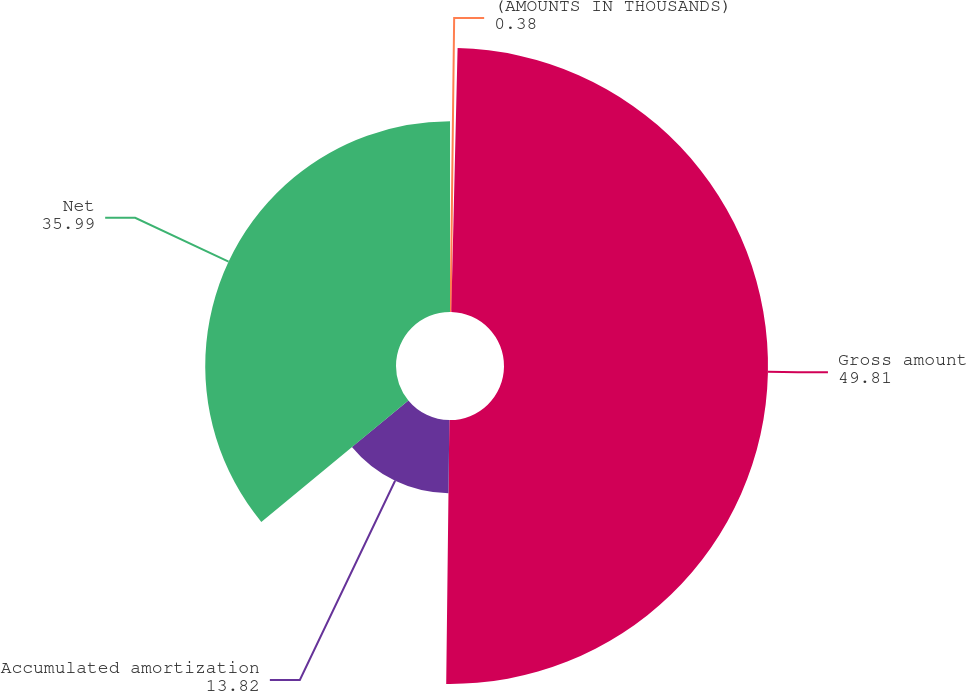Convert chart. <chart><loc_0><loc_0><loc_500><loc_500><pie_chart><fcel>(AMOUNTS IN THOUSANDS)<fcel>Gross amount<fcel>Accumulated amortization<fcel>Net<nl><fcel>0.38%<fcel>49.81%<fcel>13.82%<fcel>35.99%<nl></chart> 